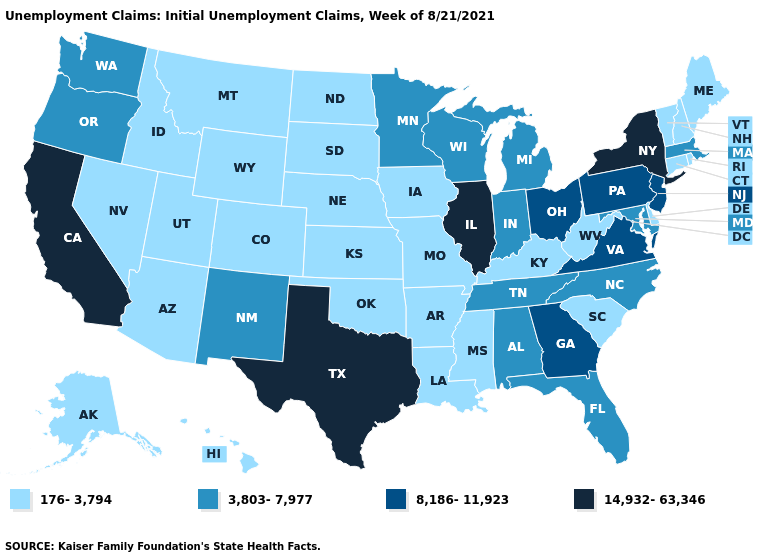Name the states that have a value in the range 8,186-11,923?
Short answer required. Georgia, New Jersey, Ohio, Pennsylvania, Virginia. Name the states that have a value in the range 3,803-7,977?
Be succinct. Alabama, Florida, Indiana, Maryland, Massachusetts, Michigan, Minnesota, New Mexico, North Carolina, Oregon, Tennessee, Washington, Wisconsin. Does Oregon have a higher value than Minnesota?
Concise answer only. No. What is the value of Alabama?
Concise answer only. 3,803-7,977. What is the value of South Carolina?
Concise answer only. 176-3,794. What is the value of Texas?
Answer briefly. 14,932-63,346. Among the states that border New Jersey , does Delaware have the lowest value?
Answer briefly. Yes. Does Hawaii have a lower value than South Dakota?
Give a very brief answer. No. Which states have the lowest value in the West?
Keep it brief. Alaska, Arizona, Colorado, Hawaii, Idaho, Montana, Nevada, Utah, Wyoming. Does the first symbol in the legend represent the smallest category?
Be succinct. Yes. Does Maine have the lowest value in the USA?
Quick response, please. Yes. Name the states that have a value in the range 14,932-63,346?
Short answer required. California, Illinois, New York, Texas. What is the highest value in states that border Virginia?
Give a very brief answer. 3,803-7,977. Name the states that have a value in the range 8,186-11,923?
Be succinct. Georgia, New Jersey, Ohio, Pennsylvania, Virginia. 